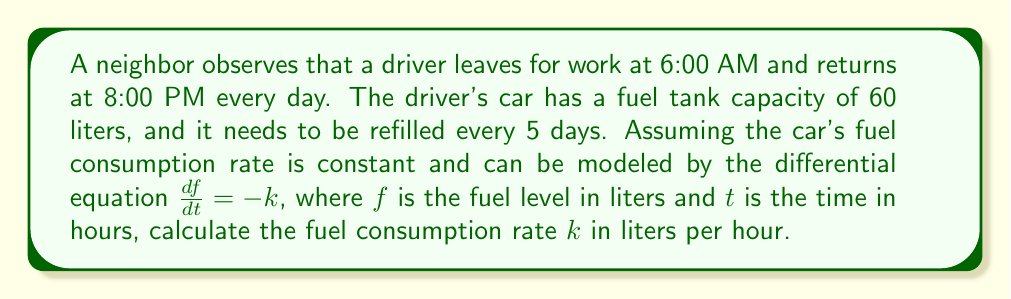Can you answer this question? Let's approach this problem step by step:

1) First, we need to determine the total time the car is in use each day:
   Time = 8:00 PM - 6:00 AM = 14 hours per day

2) Over 5 days, the total time of car use is:
   Total time = 14 hours/day * 5 days = 70 hours

3) We know that the fuel tank capacity is 60 liters, and it's completely used over 5 days.

4) The differential equation given is $\frac{df}{dt} = -k$, where $k$ is the constant fuel consumption rate.

5) Integrating both sides of the equation:
   $$\int_{f_0}^{f} df = -k \int_{0}^{t} dt$$
   $$f - f_0 = -kt$$

6) We know that $f_0 = 60$ (full tank) and $f = 0$ (empty tank) after 70 hours.
   Substituting these values:
   $$0 - 60 = -k(70)$$
   $$-60 = -70k$$

7) Solving for $k$:
   $$k = \frac{60}{70} = \frac{6}{7} \approx 0.8571$$

Therefore, the fuel consumption rate is $\frac{6}{7}$ liters per hour.
Answer: $k = \frac{6}{7}$ liters/hour or approximately 0.8571 liters/hour 